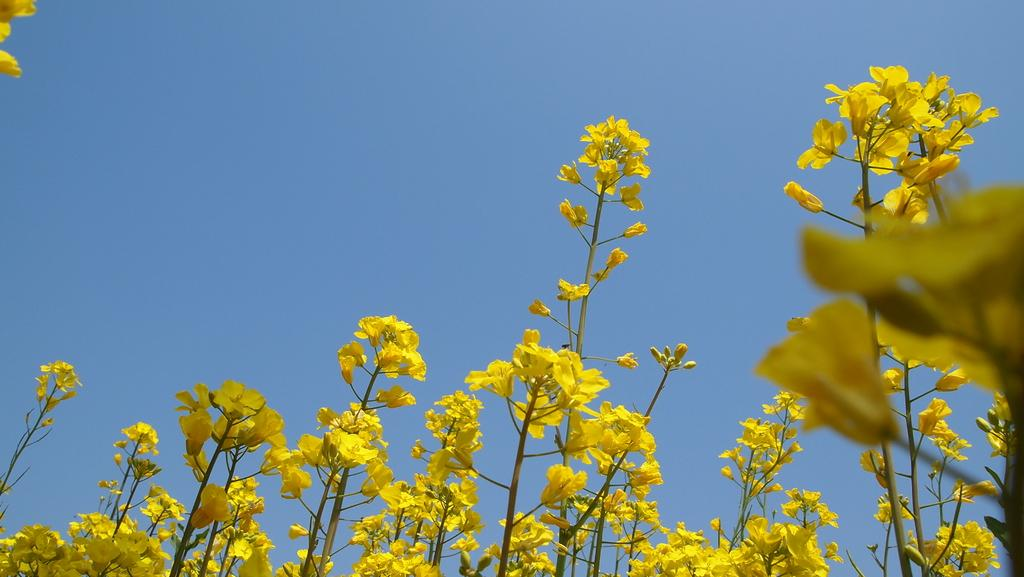What type of plants can be seen in the image? There are flowers in the image. What color is the background of the image? The background of the image is blue. What type of sponge is being used by the government in the image? There is no sponge or reference to the government present in the image. 